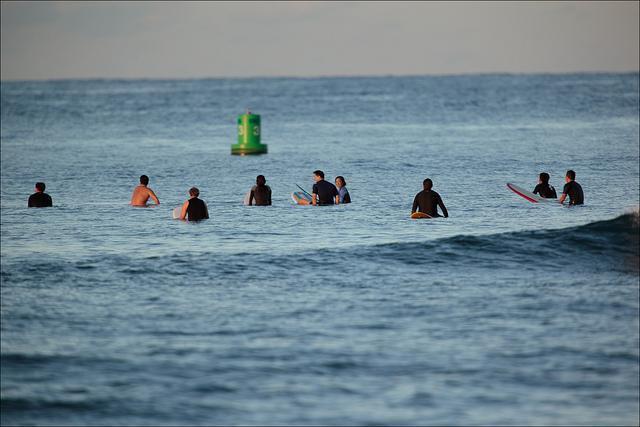How many chairs don't have a dog on them?
Give a very brief answer. 0. 